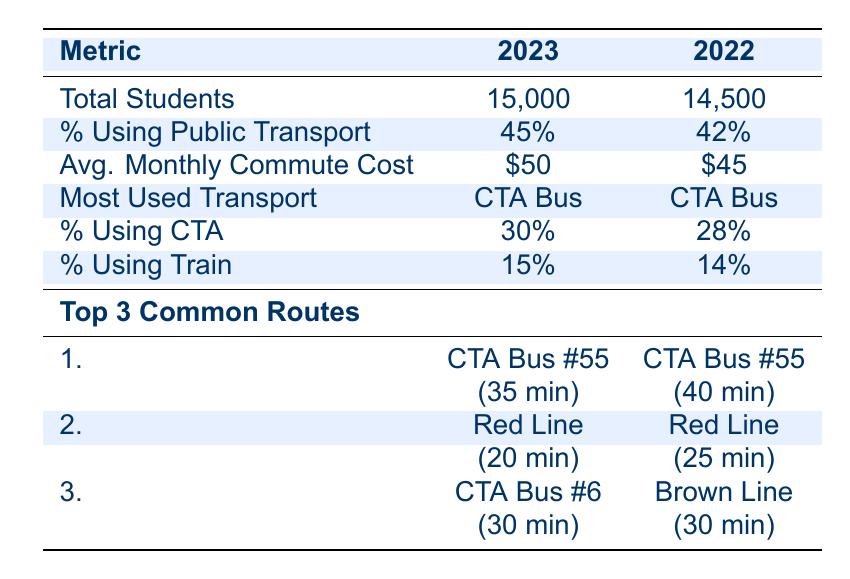What percentage of students used public transport in 2023? The table shows that in 2023, the percentage of students using public transport is listed as 45%.
Answer: 45% How much was the average monthly commute cost for students in 2022? According to the table, the average monthly commute cost for students in 2022 is $45.
Answer: $45 What is the most used type of transportation among students for both years? The table indicates that the most used type of transportation for both 2023 and 2022 is the CTA Bus.
Answer: CTA Bus Which public transport route had the lowest typical commute time in 2023? In 2023, the route with the lowest typical commute time listed in the table is the Red Line, which takes 20 minutes.
Answer: Red Line Did the percentage of students using public transport increase from 2022 to 2023? The percentage rose from 42% in 2022 to 45% in 2023, indicating an increase in public transport usage among students.
Answer: Yes How much more did students pay on average for their monthly commute in 2023 compared to 2022? To find the difference, subtract the average monthly cost in 2022 from that in 2023: $50 - $45 = $5.
Answer: $5 What is the typical commute time for CTA Bus #55 in 2022? The table shows that the typical commute time for CTA Bus #55 in 2022 is 40 minutes.
Answer: 40 minutes How many more students used public transportation in 2023 compared to 2022? To find the difference in public transport users, first find the number of students using public transport: 2023 has 15,000 students * 45% = 6,750 and 2022 has 14,500 students * 42% = 6,090. The difference is 6,750 - 6,090 = 660.
Answer: 660 Which common route had the same typical commute time in both years? The Brown Line had a typical commute time of 30 minutes in 2022, and while CTA Bus #6 is listed for 2023, it also has a commute time of 30 minutes but is for different years; thus, only Brown Line fits the requirement.
Answer: Brown Line 